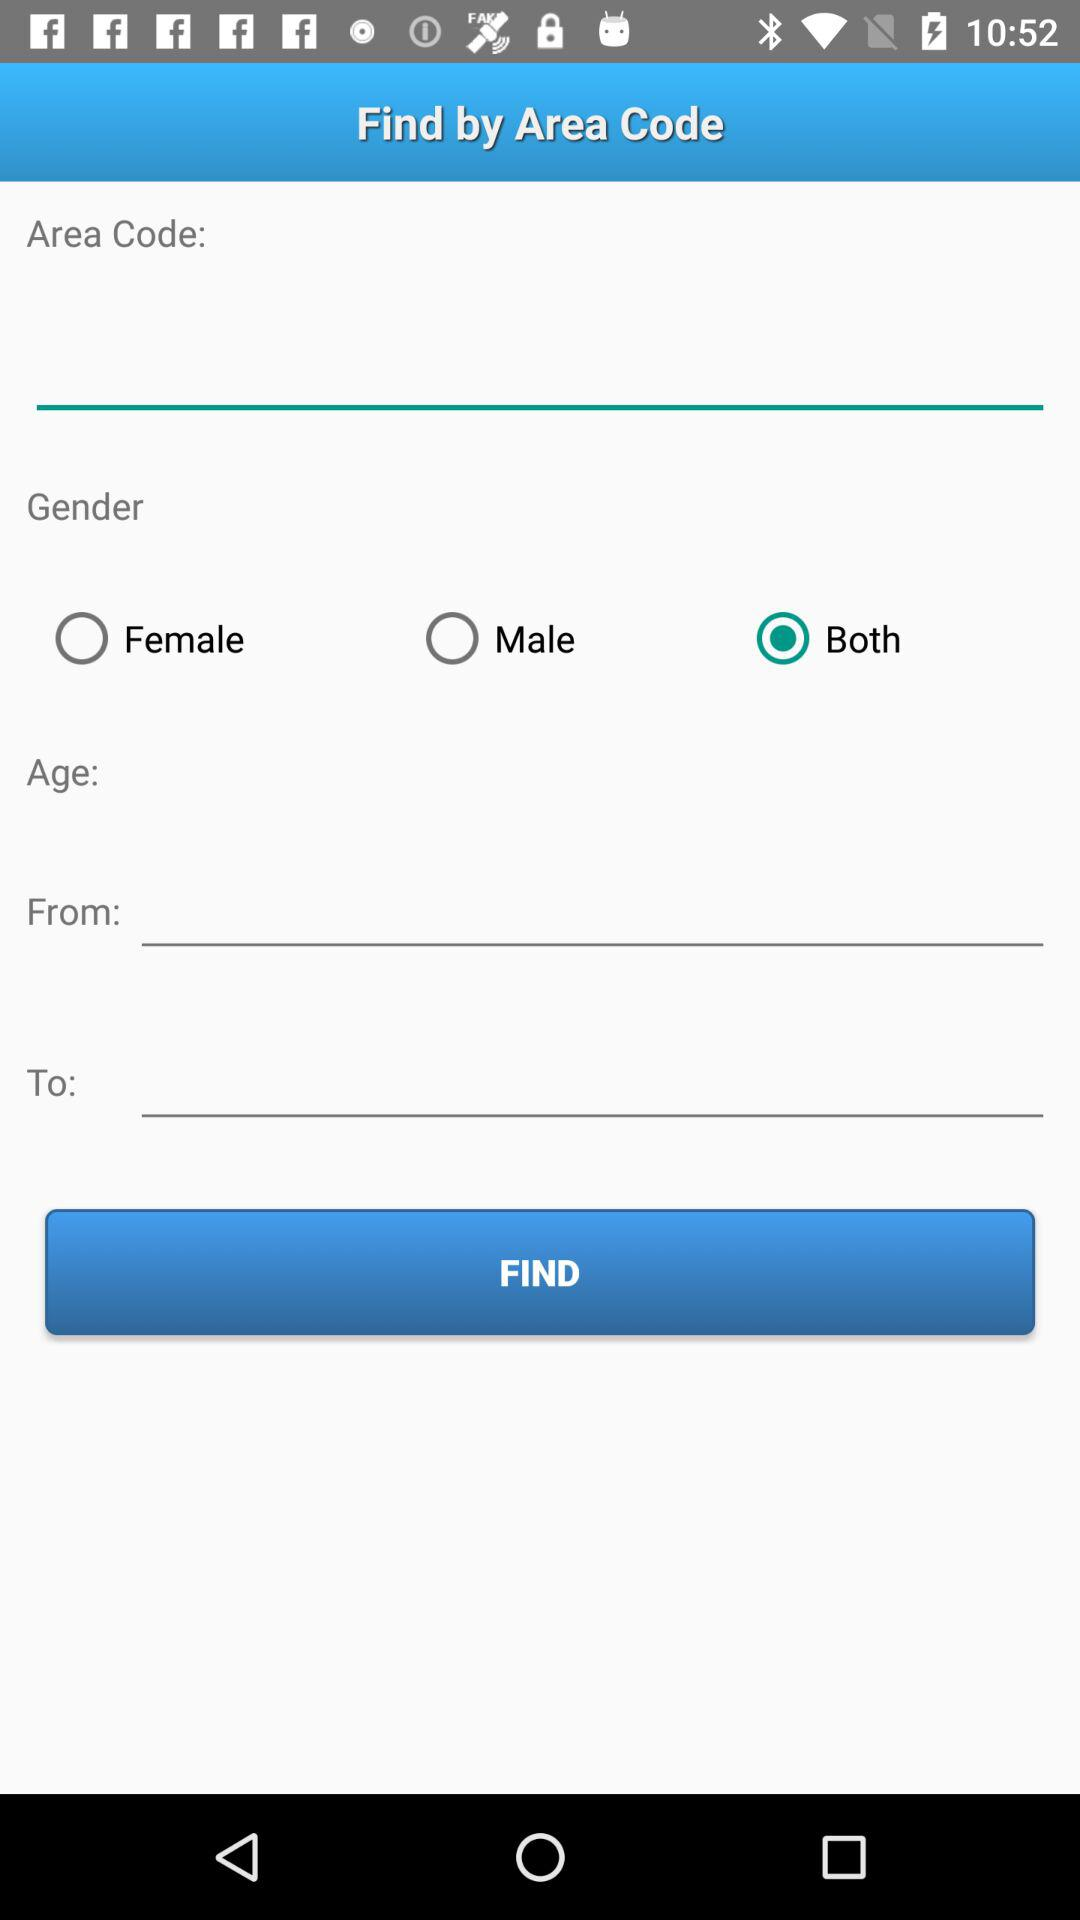Which is the selected radio button? The selected radio button is "Both". 